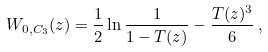<formula> <loc_0><loc_0><loc_500><loc_500>W _ { 0 , C _ { 3 } } ( z ) = \frac { 1 } { 2 } \ln { \frac { 1 } { 1 - T ( z ) } } - \frac { T ( z ) ^ { 3 } } { 6 } \, ,</formula> 